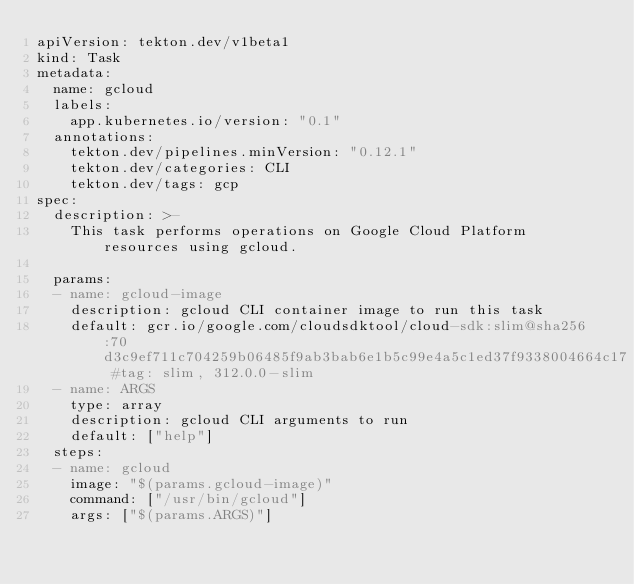<code> <loc_0><loc_0><loc_500><loc_500><_YAML_>apiVersion: tekton.dev/v1beta1
kind: Task
metadata:
  name: gcloud
  labels:
    app.kubernetes.io/version: "0.1"
  annotations:
    tekton.dev/pipelines.minVersion: "0.12.1"
    tekton.dev/categories: CLI
    tekton.dev/tags: gcp
spec:
  description: >-
    This task performs operations on Google Cloud Platform resources using gcloud.

  params:
  - name: gcloud-image
    description: gcloud CLI container image to run this task
    default: gcr.io/google.com/cloudsdktool/cloud-sdk:slim@sha256:70d3c9ef711c704259b06485f9ab3bab6e1b5c99e4a5c1ed37f9338004664c17 #tag: slim, 312.0.0-slim
  - name: ARGS
    type: array
    description: gcloud CLI arguments to run
    default: ["help"]
  steps:
  - name: gcloud
    image: "$(params.gcloud-image)"
    command: ["/usr/bin/gcloud"]
    args: ["$(params.ARGS)"]
</code> 